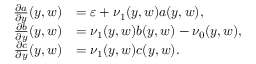<formula> <loc_0><loc_0><loc_500><loc_500>\begin{array} { r l } { \frac { \partial a } { \partial y } ( y , w ) } & { = \varepsilon + \nu _ { 1 } ( y , w ) a ( y , w ) , } \\ { \frac { \partial b } { \partial y } ( y , w ) } & { = \nu _ { 1 } ( y , w ) b ( y , w ) - \nu _ { 0 } ( y , w ) , } \\ { \frac { \partial c } { \partial y } ( y , w ) } & { = \nu _ { 1 } ( y , w ) c ( y , w ) . } \end{array}</formula> 